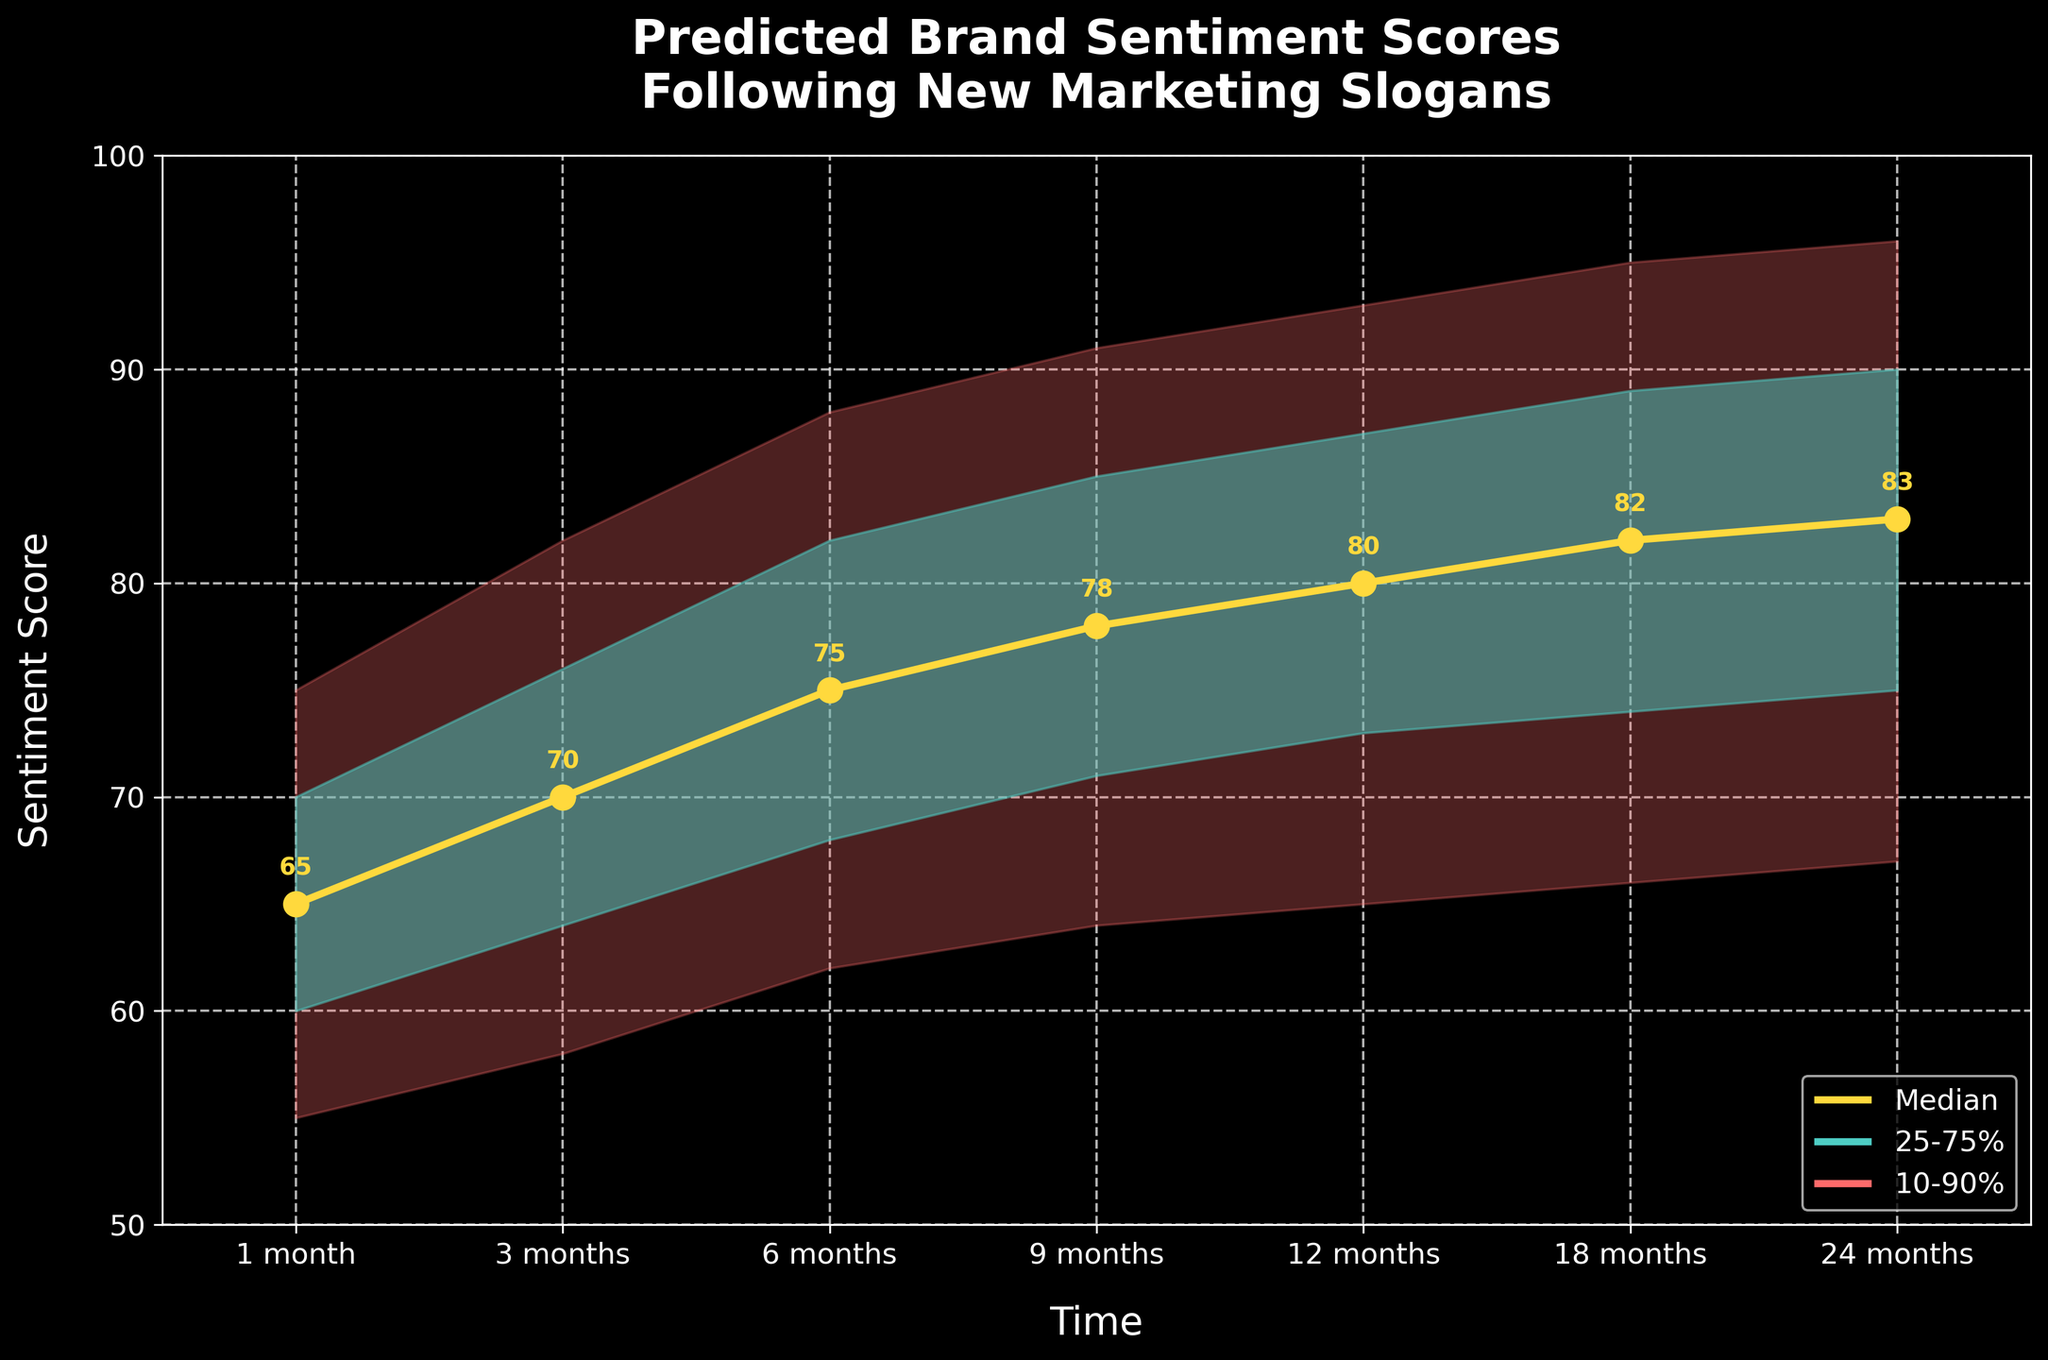How many time intervals are plotted on the x-axis? By counting the number of labeled time intervals on the x-axis, we can determine there are 7 intervals plotted which are from 1 month to 24 months.
Answer: 7 What is the title of the figure? The title is displayed at the top of the figure, indicating the subject of the chart. It reads "Predicted Brand Sentiment Scores Following New Marketing Slogans".
Answer: Predicted Brand Sentiment Scores Following New Marketing Slogans What is the median sentiment score at 9 months? The median sentiment score at 9 months is shown in yellow on the figure, represented by both the data point and its annotation, which is 78.
Answer: 78 In which time interval is the range between the lower 10% and upper 90% the widest? By examining the gap between the lower 10% and upper 90% bands across different intervals, the widest range appears at 12 months. The difference between the upper 90% (93) and the lower 10% (65) is 28, the highest among all intervals.
Answer: 12 months Which color represents the 25-75% prediction band? The color used to fill the 25-75% prediction band is a light turquoise, specifically shown in the legend and chart filling.
Answer: Light turquoise What is the difference between the median sentiment score at 24 months and 1 month? The difference between the median sentiment score at 24 months (83) and 1 month (65) is calculated as 83 - 65.
Answer: 18 Compare the lower 25% score at 6 months with the median score at 1 month. Which one is higher? By examining the values, the lower 25% score at 6 months is 68, while the median score at 1 month is 65. Hence, the lower 25% score at 6 months is higher.
Answer: Lower 25% at 6 months Is the upper 90% sentiment score at any interval higher than 95? If so, at which intervals? By scanning the upper 90% band across all intervals, the scores exceed 95 only at 24 months where it is exactly 96.
Answer: 24 months How does the sentiment score trend over time based on the median values? Observing the median line over time, it steadily increases from 65 at 1 month to 83 at 24 months, indicating an overall upward trend in sentiment scores.
Answer: Upward trend 